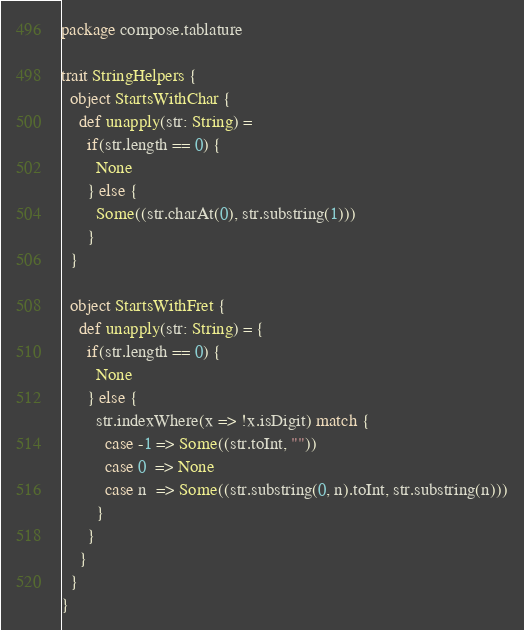Convert code to text. <code><loc_0><loc_0><loc_500><loc_500><_Scala_>package compose.tablature

trait StringHelpers {
  object StartsWithChar {
    def unapply(str: String) =
      if(str.length == 0) {
        None
      } else {
        Some((str.charAt(0), str.substring(1)))
      }
  }

  object StartsWithFret {
    def unapply(str: String) = {
      if(str.length == 0) {
        None
      } else {
        str.indexWhere(x => !x.isDigit) match {
          case -1 => Some((str.toInt, ""))
          case 0  => None
          case n  => Some((str.substring(0, n).toInt, str.substring(n)))
        }
      }
    }
  }
}</code> 